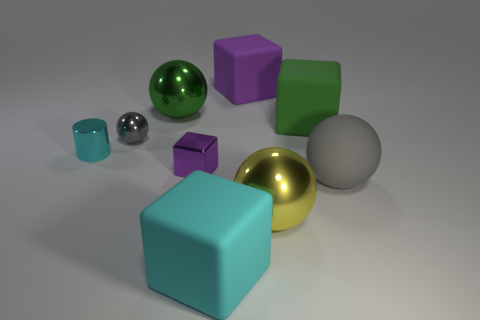Add 1 large gray matte spheres. How many objects exist? 10 Subtract all cubes. How many objects are left? 5 Add 6 green rubber blocks. How many green rubber blocks exist? 7 Subtract 0 blue cylinders. How many objects are left? 9 Subtract all small green blocks. Subtract all big green metal objects. How many objects are left? 8 Add 7 big green metallic objects. How many big green metallic objects are left? 8 